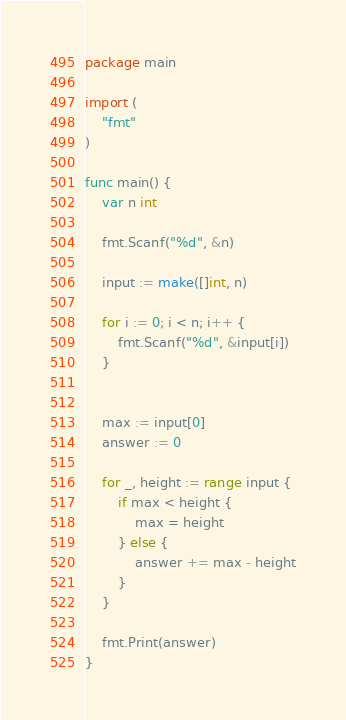<code> <loc_0><loc_0><loc_500><loc_500><_Go_>package main

import (
	"fmt"
)

func main() {
	var n int

	fmt.Scanf("%d", &n)

	input := make([]int, n)

	for i := 0; i < n; i++ {
		fmt.Scanf("%d", &input[i])
	}


	max := input[0]
	answer := 0

	for _, height := range input {
		if max < height {
			max = height
		} else {
			answer += max - height
		}
	}

	fmt.Print(answer)
}</code> 